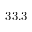<formula> <loc_0><loc_0><loc_500><loc_500>3 3 . 3</formula> 